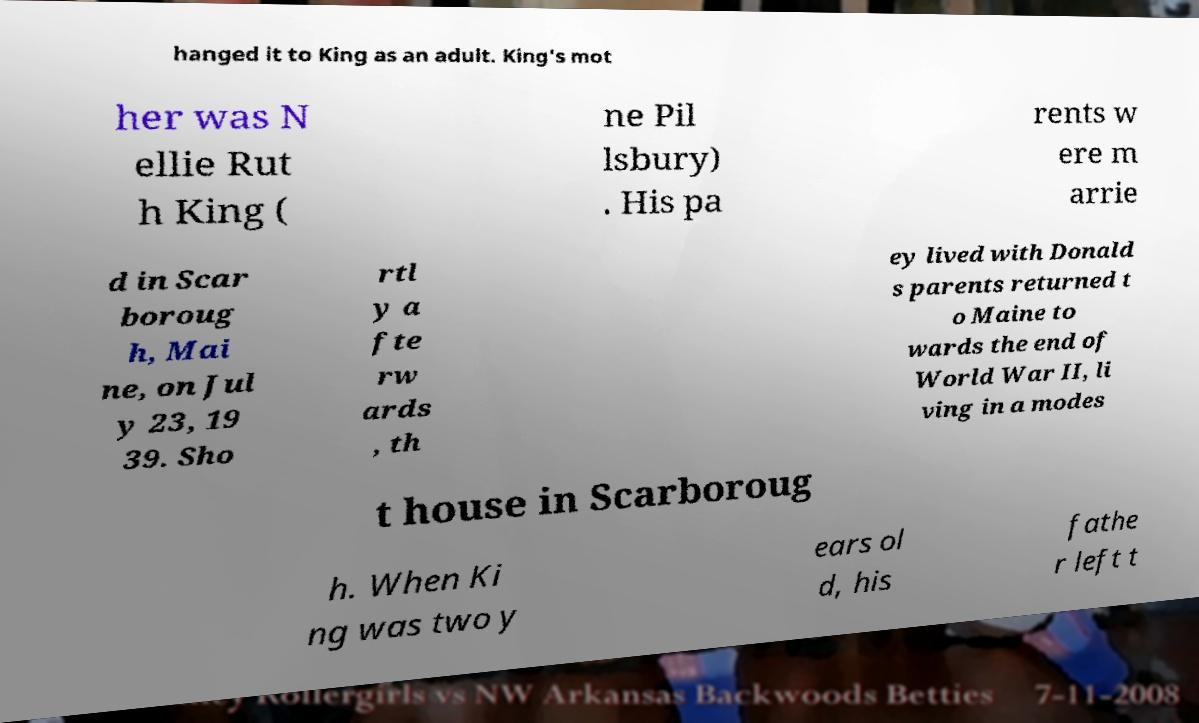Can you accurately transcribe the text from the provided image for me? hanged it to King as an adult. King's mot her was N ellie Rut h King ( ne Pil lsbury) . His pa rents w ere m arrie d in Scar boroug h, Mai ne, on Jul y 23, 19 39. Sho rtl y a fte rw ards , th ey lived with Donald s parents returned t o Maine to wards the end of World War II, li ving in a modes t house in Scarboroug h. When Ki ng was two y ears ol d, his fathe r left t 